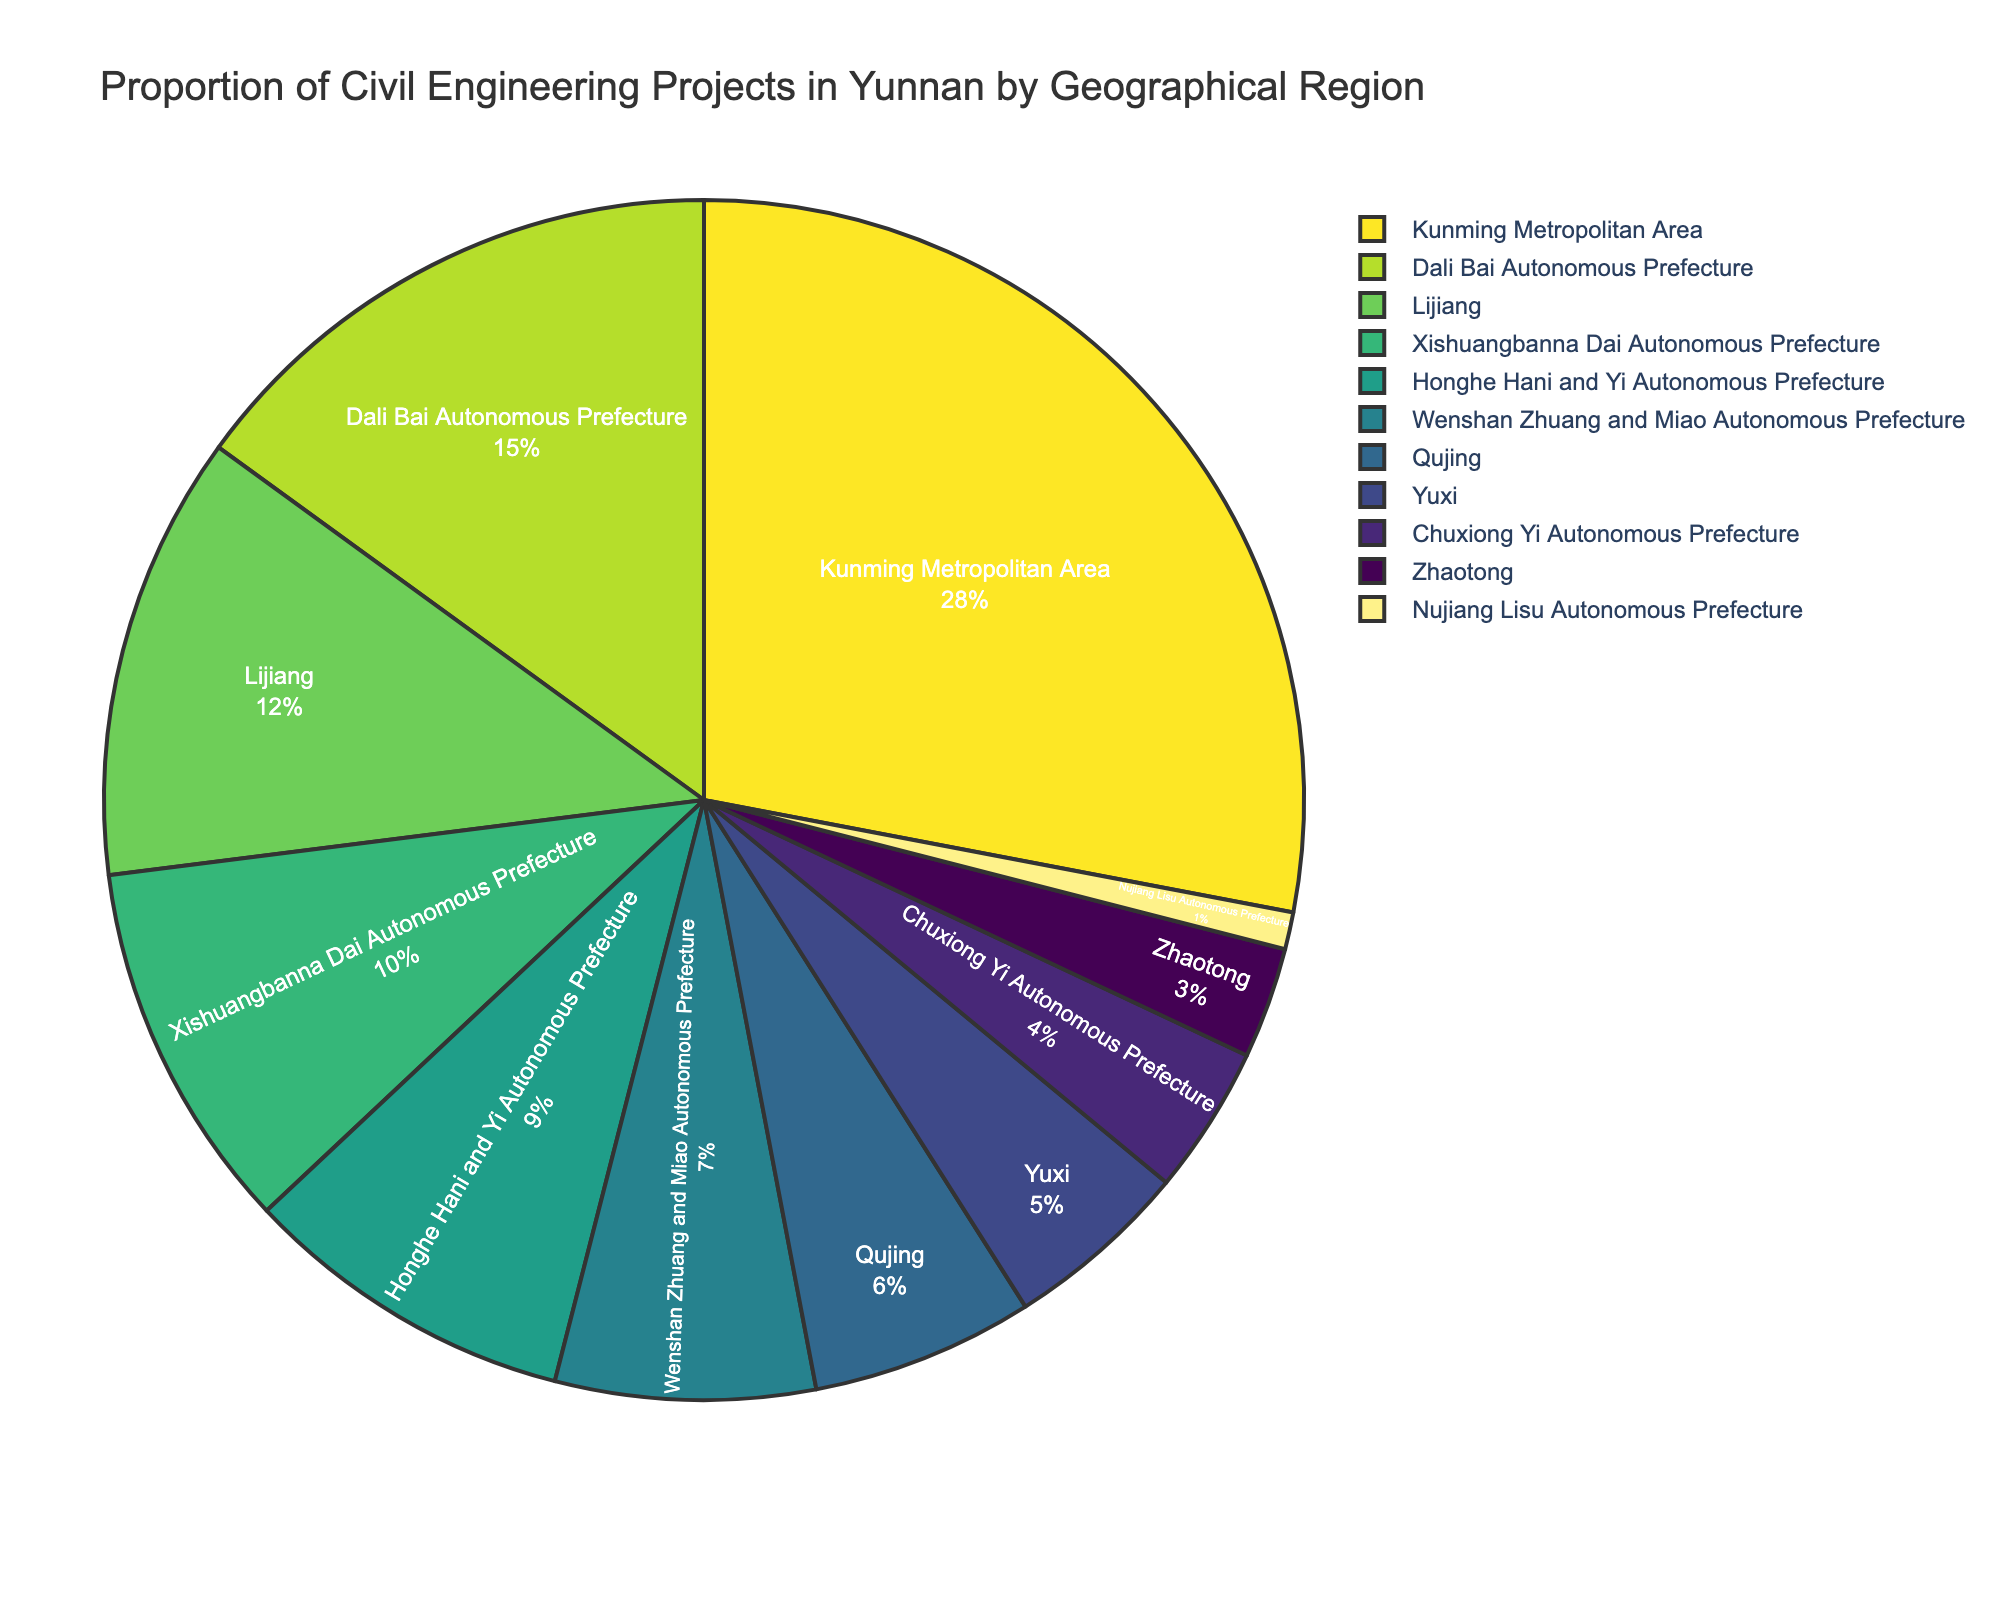Which region has the highest proportion of civil engineering projects? The region with the highest proportion is the one with the largest segment in the pie chart. Kunming Metropolitan Area takes up the largest portion.
Answer: Kunming Metropolitan Area Which regions together account for 27% of the civil engineering projects? We need to find a combination of regions whose percentages add up to 27%. The regions are Wenshan Zhuang and Miao Autonomous Prefecture (7%), Qujing (6%), Yuxi (5%), and Chuxiong Yi Autonomous Prefecture (4%), which totals 22%, and adding Zhaotong (3%) reaches 25%. Additionally, adding Nujiang Lisu Autonomous Prefecture (1%) reaches 26%.
Answer: Wenshan Zhuang and Miao Autonomous Prefecture, Qujing, Yuxi, Chuxiong Yi Autonomous Prefecture, Zhaotong, Nujiang Lisu Autonomous Prefecture What is the total percentage of projects in the top three regions? We sum the percentages of the top three regions: Kunming Metropolitan Area (28%), Dali Bai Autonomous Prefecture (15%), and Lijiang (12%). The total is 28 + 15 + 12 = 55%.
Answer: 55% Which region has a smaller proportion of projects: Xishuangbanna Dai Autonomous Prefecture or Qujing? The region with the smaller proportion is the one with the smaller segment in the pie chart. Xishuangbanna Dai Autonomous Prefecture has 10%, while Qujing has 6%.
Answer: Qujing How does the proportion of projects in Dali Bai Autonomous Prefecture compare to the combined proportion of Honghe Hani and Yi Autonomous Prefecture and Wenshan Zhuang and Miao Autonomous Prefecture? Dali Bai Autonomous Prefecture has 15%. Combining Honghe Hani and Yi Autonomous Prefecture (9%) and Wenshan Zhuang and Miao Autonomous Prefecture (7%) gives 9 + 7 = 16%. Dali has a smaller proportion than the combined total.
Answer: Smaller What is the difference in project proportion between the largest and smallest regions? The largest region is Kunming Metropolitan Area with 28%, and the smallest region is Nujiang Lisu Autonomous Prefecture with 1%. The difference is 28 - 1 = 27%.
Answer: 27% Evaluate the sum of project proportions in autonomous prefectures. Summing the percentages of all the autonomous prefectures: Dali Bai Autonomous Prefecture (15%), Xishuangbanna Dai Autonomous Prefecture (10%), Honghe Hani and Yi Autonomous Prefecture (9%), Wenshan Zhuang and Miao Autonomous Prefecture (7%), Chuxiong Yi Autonomous Prefecture (4%), and Nujiang Lisu Autonomous Prefecture (1%). The total is 15 + 10 + 9 + 7 + 4 + 1 = 46%.
Answer: 46% By how much does the proportion of projects in Kunming Metropolitan Area exceed that in Yuxi? Kunming Metropolitan Area has 28% and Yuxi has 5%. The difference is 28 - 5 = 23%.
Answer: 23% If you add up the proportions of Lijiang and Xishuangbanna Dai Autonomous Prefecture, is it more or less than the proportion of the Dali Bai Autonomous Prefecture? Lijiang has 12% and Xishuangbanna Dai Autonomous Prefecture has 10%. Their sum is 12 + 10 = 22%, which is greater than Dali Bai Autonomous Prefecture’s 15%.
Answer: More 